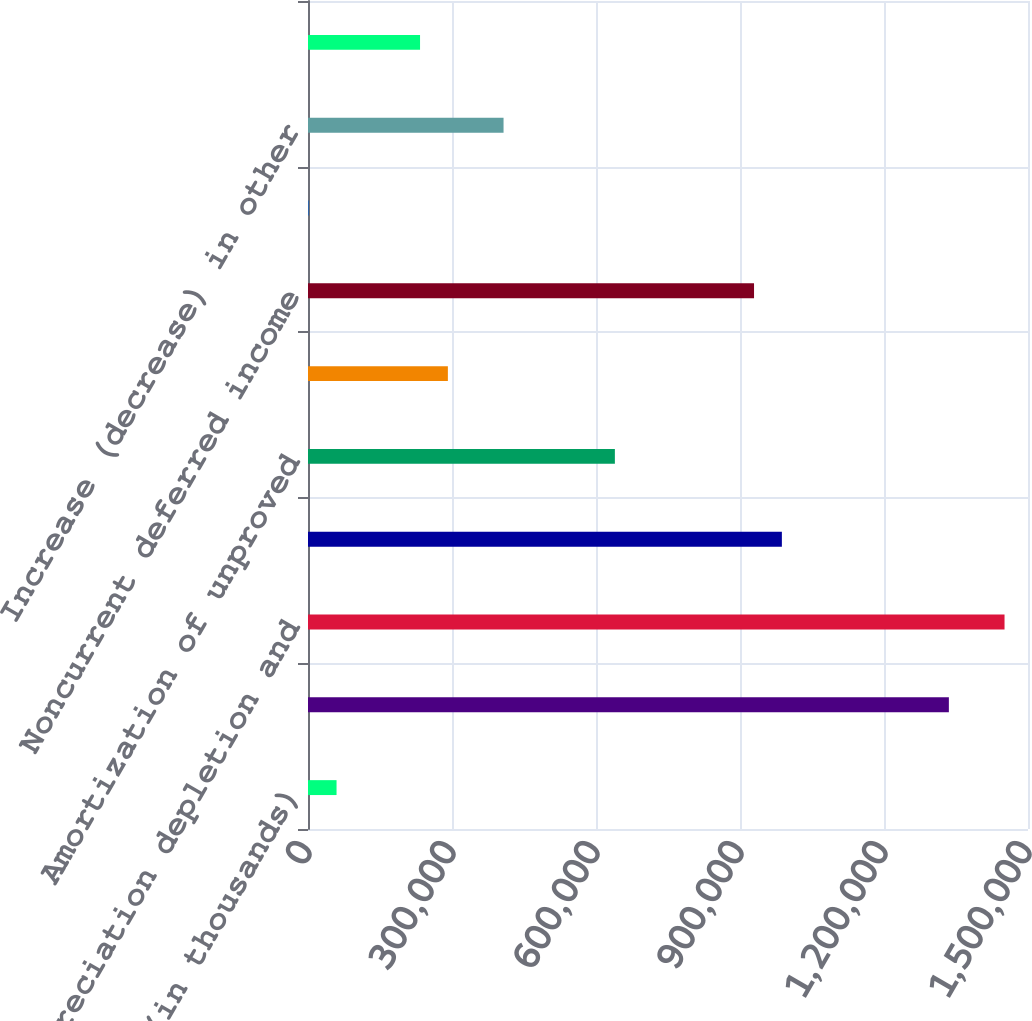<chart> <loc_0><loc_0><loc_500><loc_500><bar_chart><fcel>(in thousands)<fcel>Net income<fcel>Depreciation depletion and<fcel>Dry hole expense<fcel>Amortization of unproved<fcel>(Gain) loss on disposal of<fcel>Noncurrent deferred income<fcel>(Income) loss from<fcel>Increase (decrease) in other<fcel>(Increase) decrease in other<nl><fcel>59473.9<fcel>1.33514e+06<fcel>1.45111e+06<fcel>987232<fcel>639323<fcel>291414<fcel>929247<fcel>1489<fcel>407383<fcel>233429<nl></chart> 